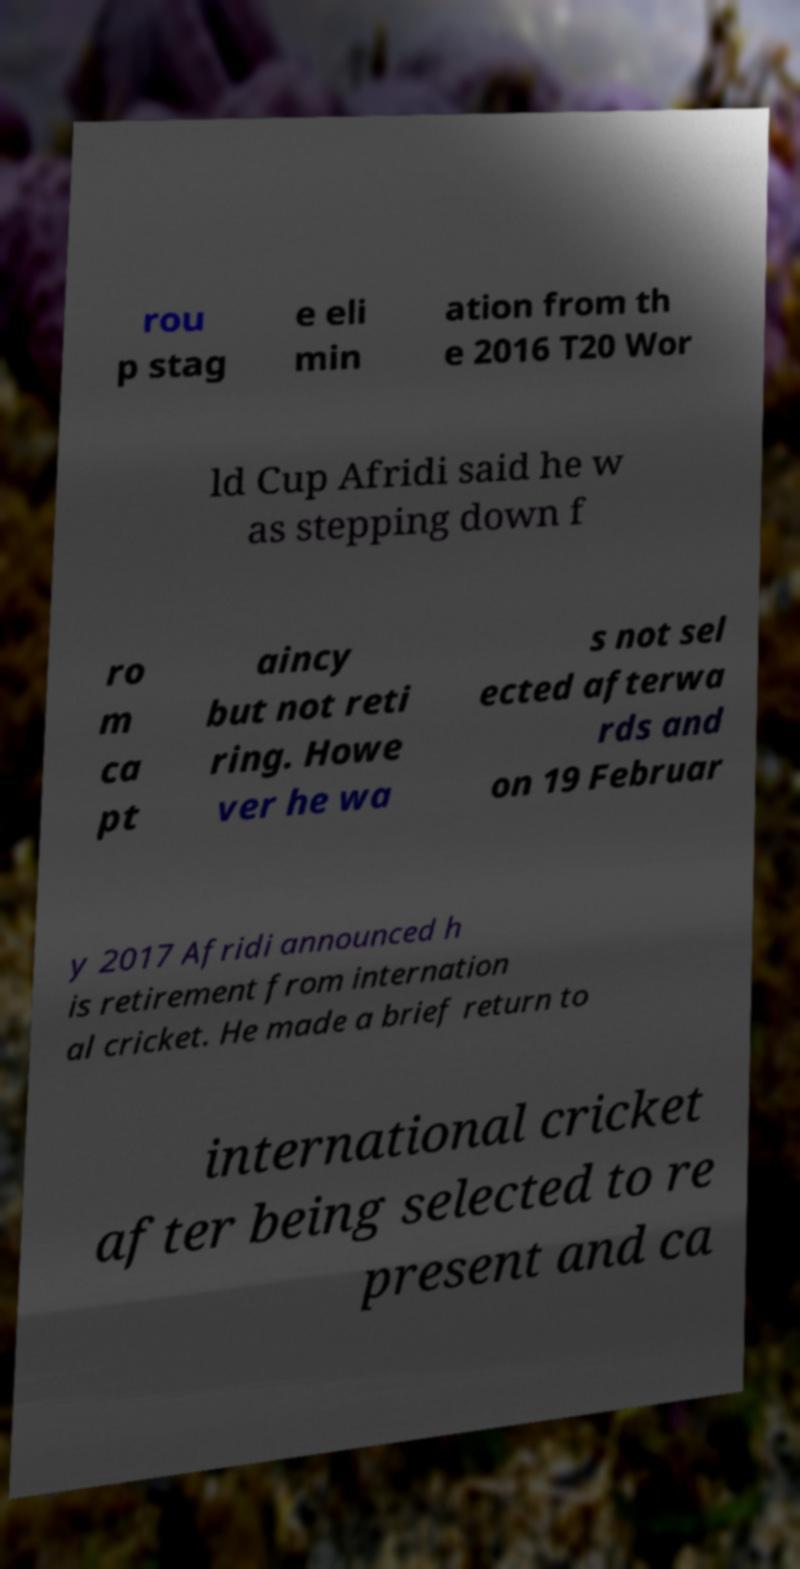Could you assist in decoding the text presented in this image and type it out clearly? rou p stag e eli min ation from th e 2016 T20 Wor ld Cup Afridi said he w as stepping down f ro m ca pt aincy but not reti ring. Howe ver he wa s not sel ected afterwa rds and on 19 Februar y 2017 Afridi announced h is retirement from internation al cricket. He made a brief return to international cricket after being selected to re present and ca 